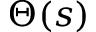<formula> <loc_0><loc_0><loc_500><loc_500>\Theta ( s )</formula> 